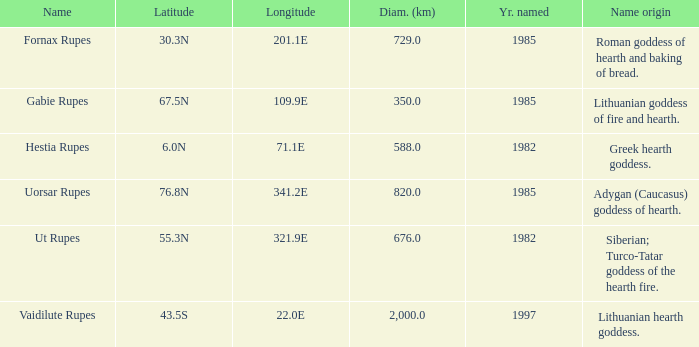At a latitude of 71.1e, what is the feature's name origin? Greek hearth goddess. Could you help me parse every detail presented in this table? {'header': ['Name', 'Latitude', 'Longitude', 'Diam. (km)', 'Yr. named', 'Name origin'], 'rows': [['Fornax Rupes', '30.3N', '201.1E', '729.0', '1985', 'Roman goddess of hearth and baking of bread.'], ['Gabie Rupes', '67.5N', '109.9E', '350.0', '1985', 'Lithuanian goddess of fire and hearth.'], ['Hestia Rupes', '6.0N', '71.1E', '588.0', '1982', 'Greek hearth goddess.'], ['Uorsar Rupes', '76.8N', '341.2E', '820.0', '1985', 'Adygan (Caucasus) goddess of hearth.'], ['Ut Rupes', '55.3N', '321.9E', '676.0', '1982', 'Siberian; Turco-Tatar goddess of the hearth fire.'], ['Vaidilute Rupes', '43.5S', '22.0E', '2,000.0', '1997', 'Lithuanian hearth goddess.']]} 